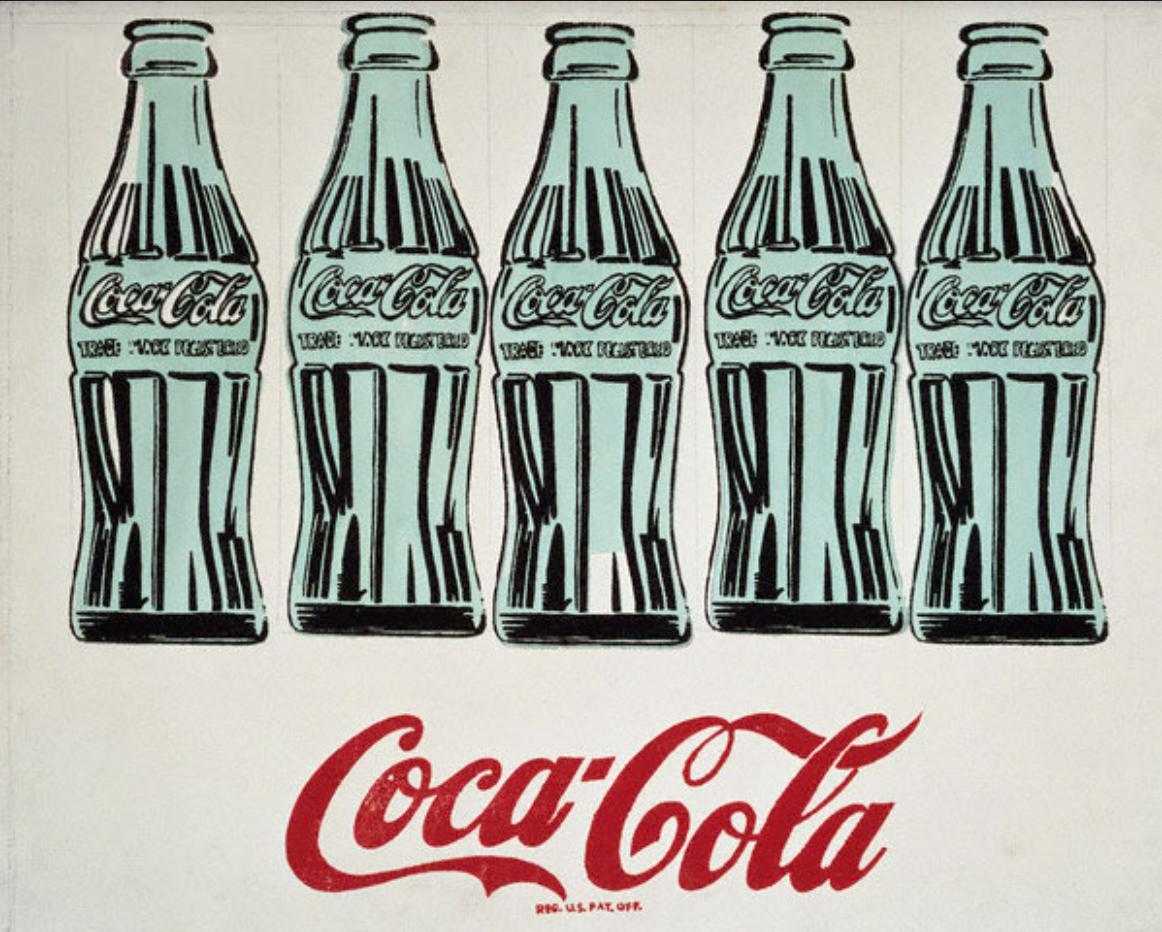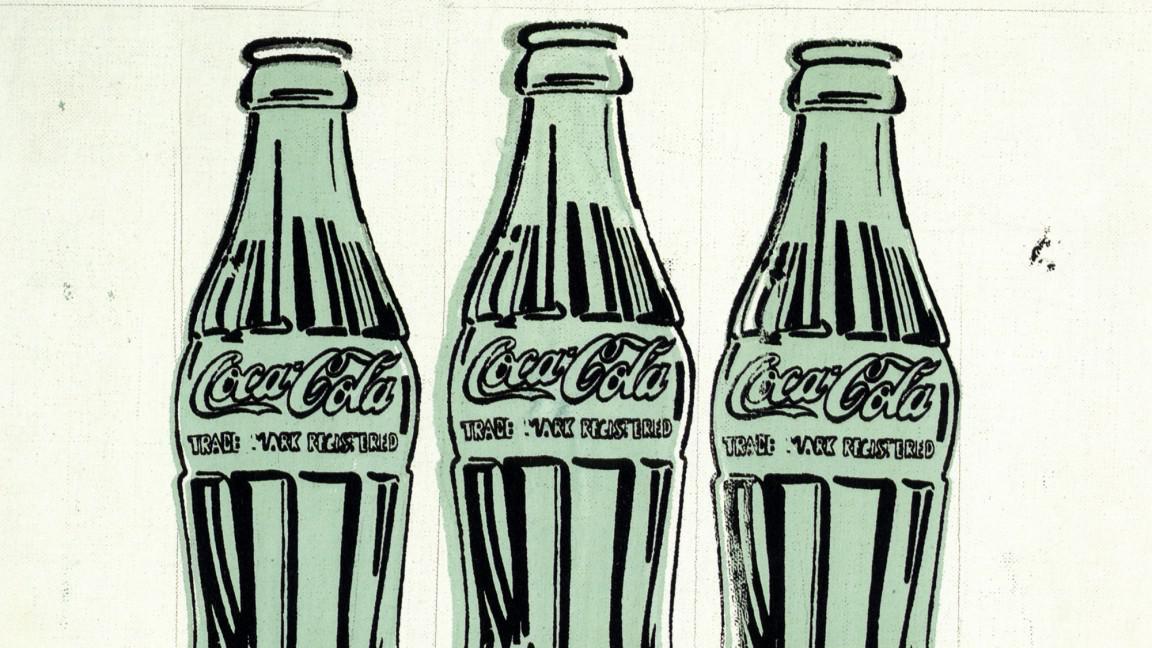The first image is the image on the left, the second image is the image on the right. Examine the images to the left and right. Is the description "There are four bottles of soda." accurate? Answer yes or no. No. The first image is the image on the left, the second image is the image on the right. Analyze the images presented: Is the assertion "The artwork in the image on the right depicts exactly three bottles." valid? Answer yes or no. Yes. 